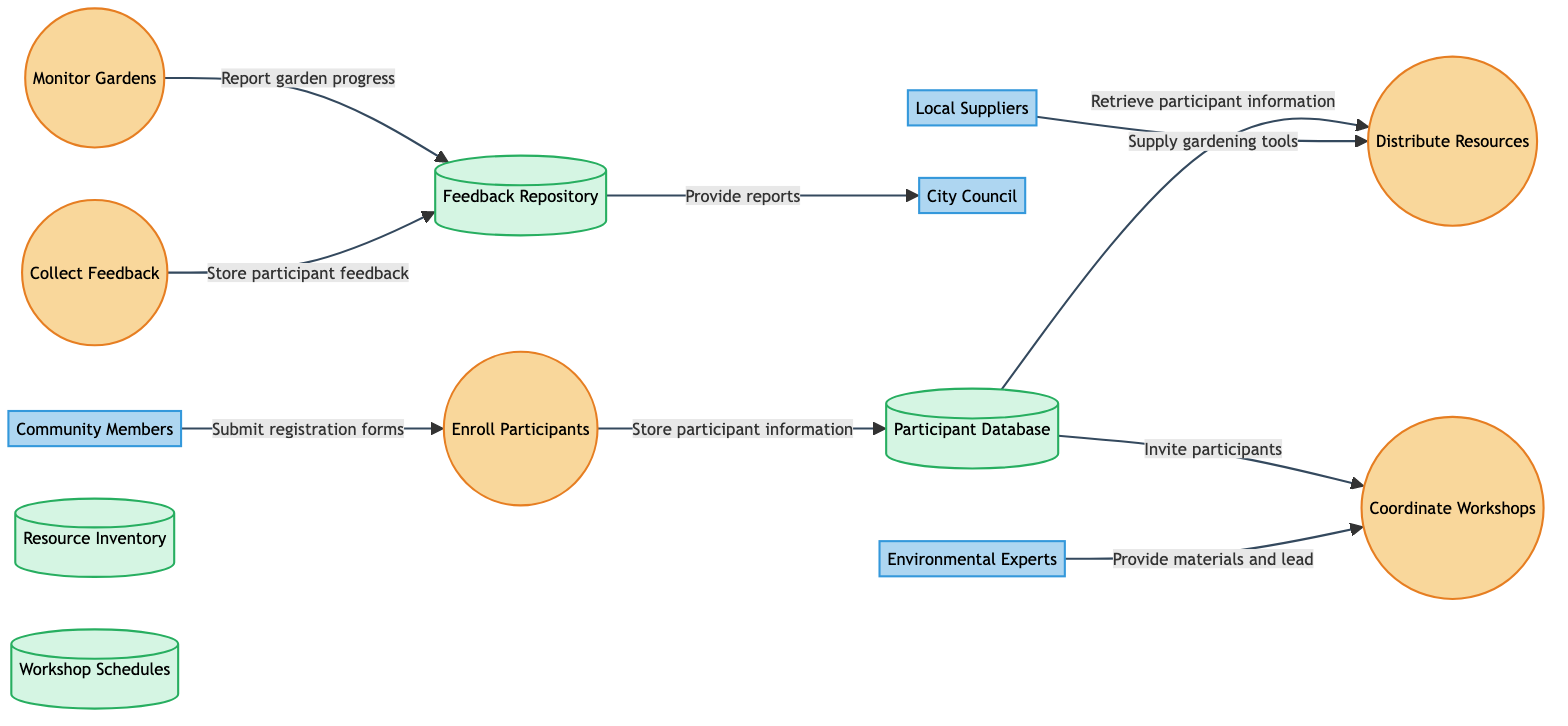What process is responsible for gathering input from participants? The process that collects feedback from participants is labeled as "Collect Feedback," which directly handles the task of gathering participant input.
Answer: Collect Feedback How many external entities are present in the diagram? The diagram includes four external entities: Community Members, Local Suppliers, City Council, and Environmental Experts. Counting each entity yields a total of four.
Answer: 4 What flow connects "Distribute Resources" to "Resource Inventory"? There is no direct flow connecting "Distribute Resources" to "Resource Inventory"; instead, there are flows that involve other processes and entities.
Answer: None Which external entity provides funding and support for the program? The entity that provides funding and support for the gardening program is the "City Council."
Answer: City Council What is the purpose of the "Participant Database"? The purpose of the "Participant Database" is to store participant registration details and contact information. This is directly indicated in the description provided for the data store.
Answer: Store participant registration details What two elements are necessary for coordinating workshops? Two key elements needed to coordinate workshops include participant information from the "Participant Database" and materials provided by "Environmental Experts." These are identified as inputs for the "Coordinate Workshops" process.
Answer: Participant Database and Environmental Experts How is workshop attendance managed among participants? Workshop attendance is managed by inviting participants through the "Coordinate Workshops" process, which references participant details stored in the "Participant Database."
Answer: Inviting participants Which process uses feedback from the monitoring of gardens? The process that incorporates feedback from the monitoring of gardens is "Collect Feedback," which specifically collects and stores information about the garden's progress and condition.
Answer: Collect Feedback What is the flow method used to report program effectiveness to the City Council? The flow method to report program effectiveness involves sending structured feedback collected in the "Feedback Repository" to the "City Council," which is indicated as providing reports on program effectiveness.
Answer: Feedback Repository to City Council 